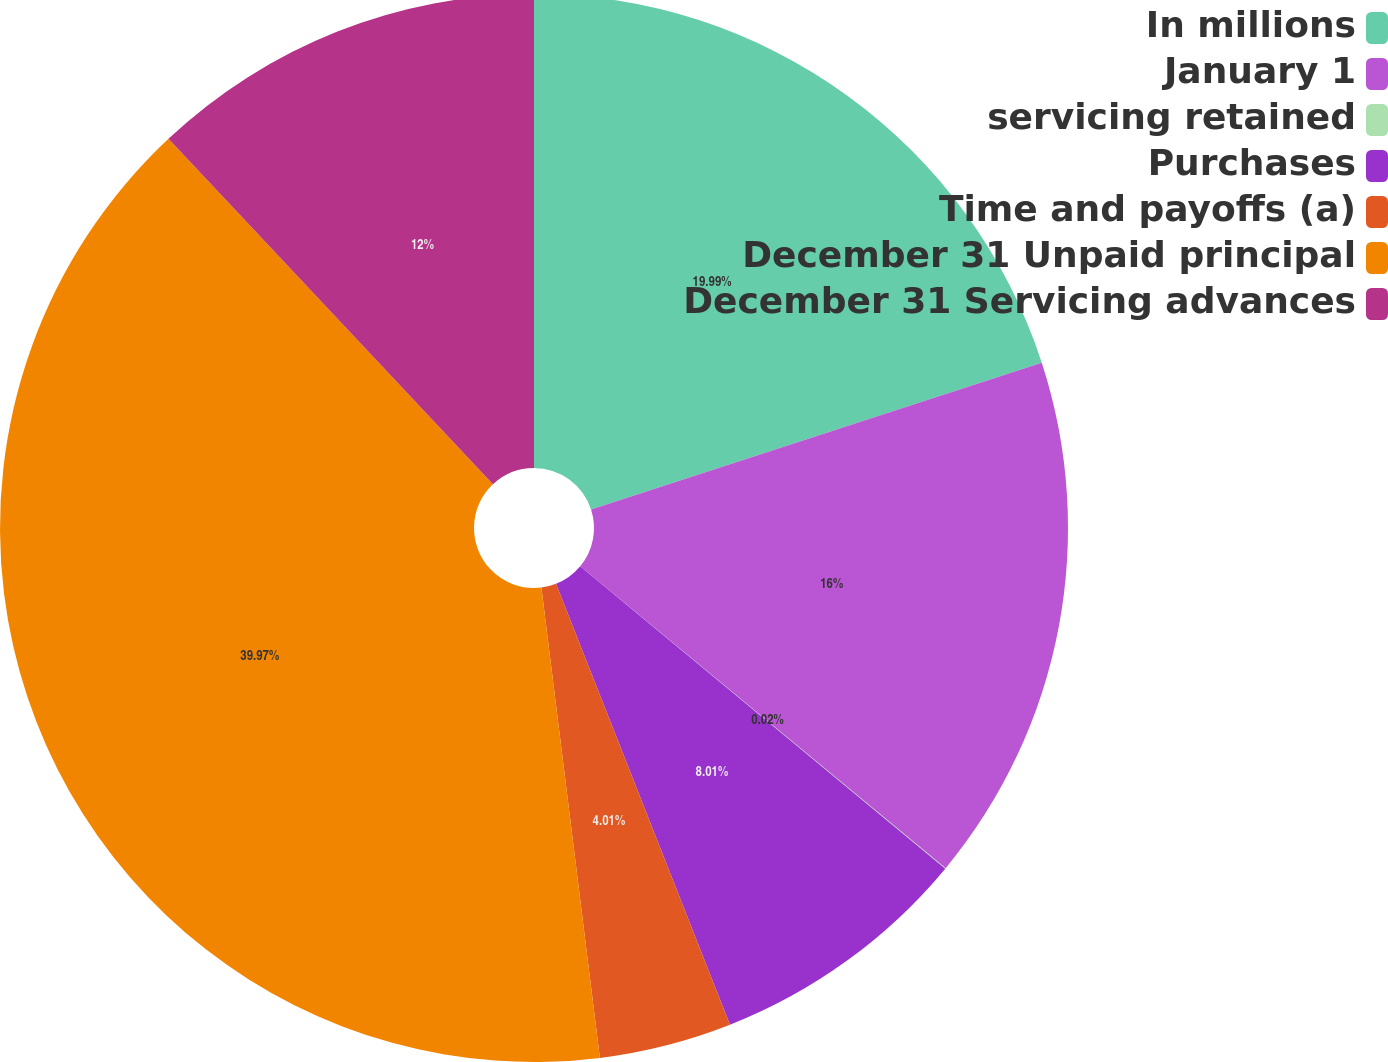Convert chart. <chart><loc_0><loc_0><loc_500><loc_500><pie_chart><fcel>In millions<fcel>January 1<fcel>servicing retained<fcel>Purchases<fcel>Time and payoffs (a)<fcel>December 31 Unpaid principal<fcel>December 31 Servicing advances<nl><fcel>19.99%<fcel>16.0%<fcel>0.02%<fcel>8.01%<fcel>4.01%<fcel>39.97%<fcel>12.0%<nl></chart> 